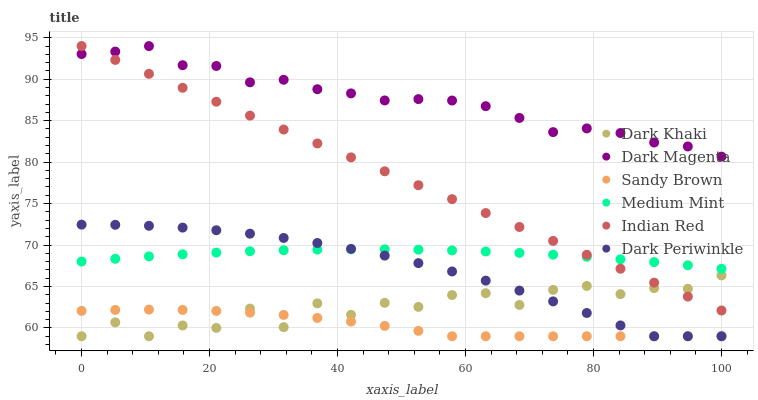Does Sandy Brown have the minimum area under the curve?
Answer yes or no. Yes. Does Dark Magenta have the maximum area under the curve?
Answer yes or no. Yes. Does Dark Khaki have the minimum area under the curve?
Answer yes or no. No. Does Dark Khaki have the maximum area under the curve?
Answer yes or no. No. Is Indian Red the smoothest?
Answer yes or no. Yes. Is Dark Khaki the roughest?
Answer yes or no. Yes. Is Dark Magenta the smoothest?
Answer yes or no. No. Is Dark Magenta the roughest?
Answer yes or no. No. Does Dark Khaki have the lowest value?
Answer yes or no. Yes. Does Dark Magenta have the lowest value?
Answer yes or no. No. Does Indian Red have the highest value?
Answer yes or no. Yes. Does Dark Magenta have the highest value?
Answer yes or no. No. Is Medium Mint less than Dark Magenta?
Answer yes or no. Yes. Is Indian Red greater than Sandy Brown?
Answer yes or no. Yes. Does Medium Mint intersect Dark Periwinkle?
Answer yes or no. Yes. Is Medium Mint less than Dark Periwinkle?
Answer yes or no. No. Is Medium Mint greater than Dark Periwinkle?
Answer yes or no. No. Does Medium Mint intersect Dark Magenta?
Answer yes or no. No. 